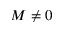Convert formula to latex. <formula><loc_0><loc_0><loc_500><loc_500>M \ne 0</formula> 